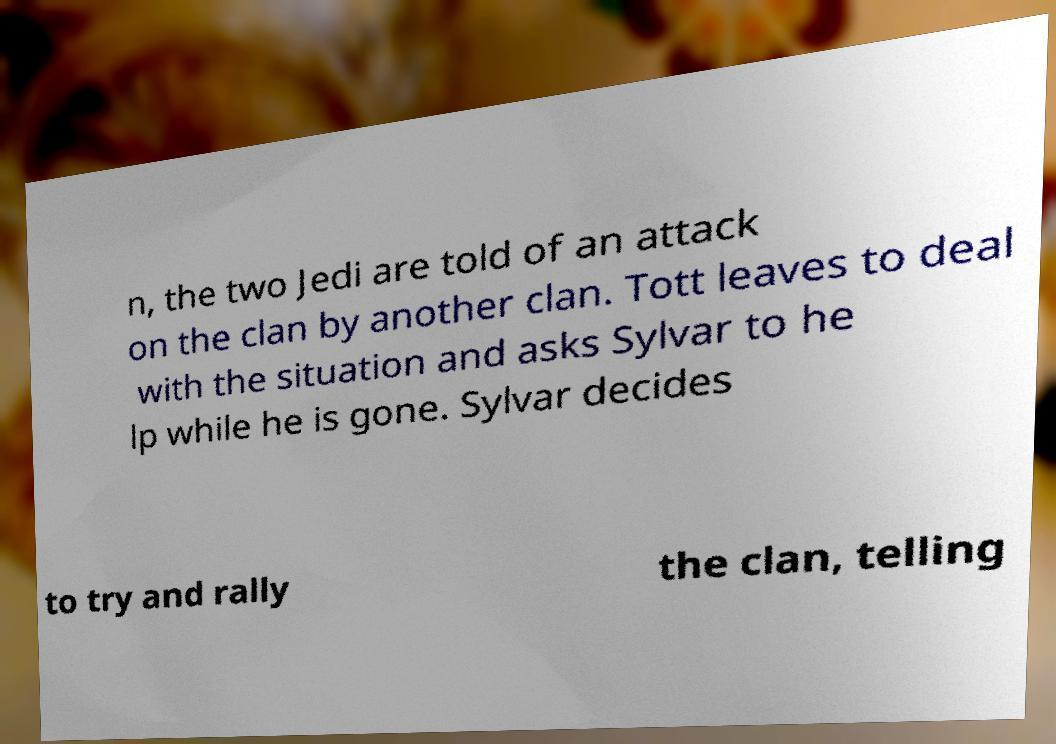For documentation purposes, I need the text within this image transcribed. Could you provide that? n, the two Jedi are told of an attack on the clan by another clan. Tott leaves to deal with the situation and asks Sylvar to he lp while he is gone. Sylvar decides to try and rally the clan, telling 